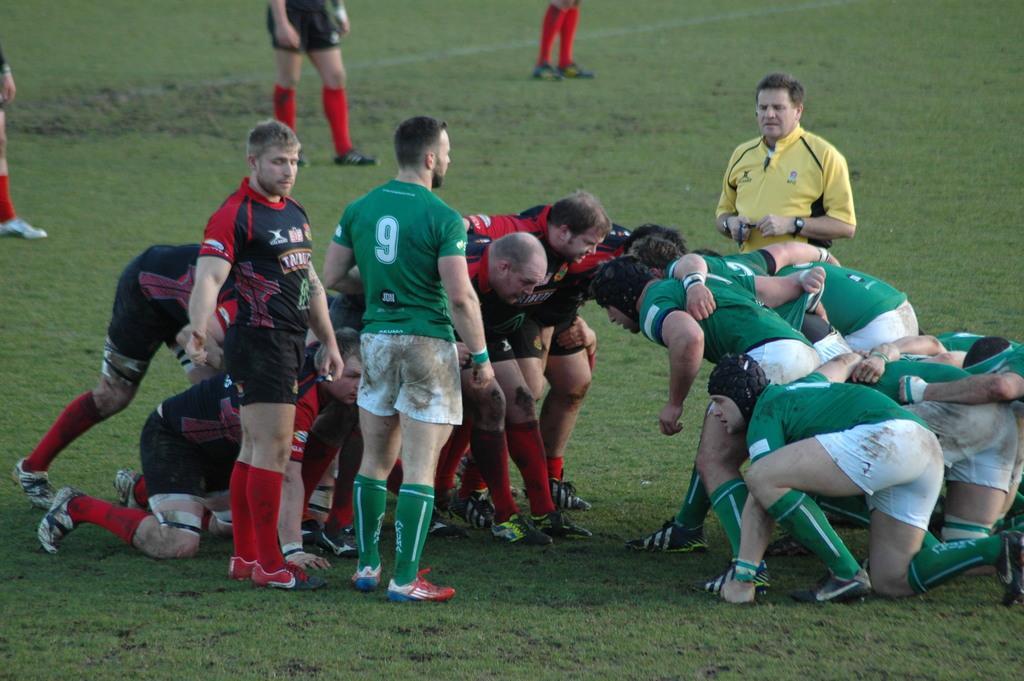How would you summarize this image in a sentence or two? In this image I can see group of people in the ground. They are wearing green,white,black and red color dress. One person is wearing yellow and black dress. 